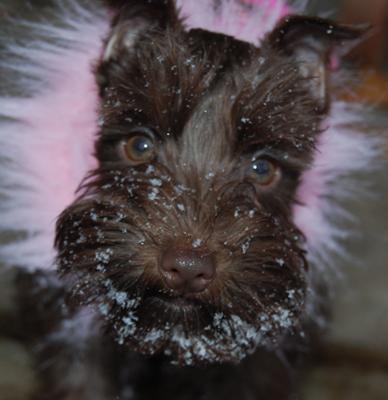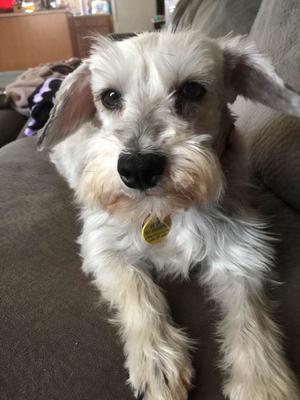The first image is the image on the left, the second image is the image on the right. Assess this claim about the two images: "Each image shows a schnauzer with light-colored 'mustache and beard' fur, and each dog faces the camera with eyes visible.". Correct or not? Answer yes or no. No. The first image is the image on the left, the second image is the image on the right. Examine the images to the left and right. Is the description "One of the dogs is wearing a round tag on its collar." accurate? Answer yes or no. Yes. 